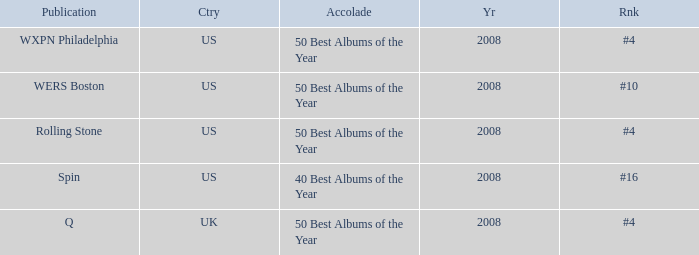Which rank's country is the US when the accolade is 40 best albums of the year? #16. 